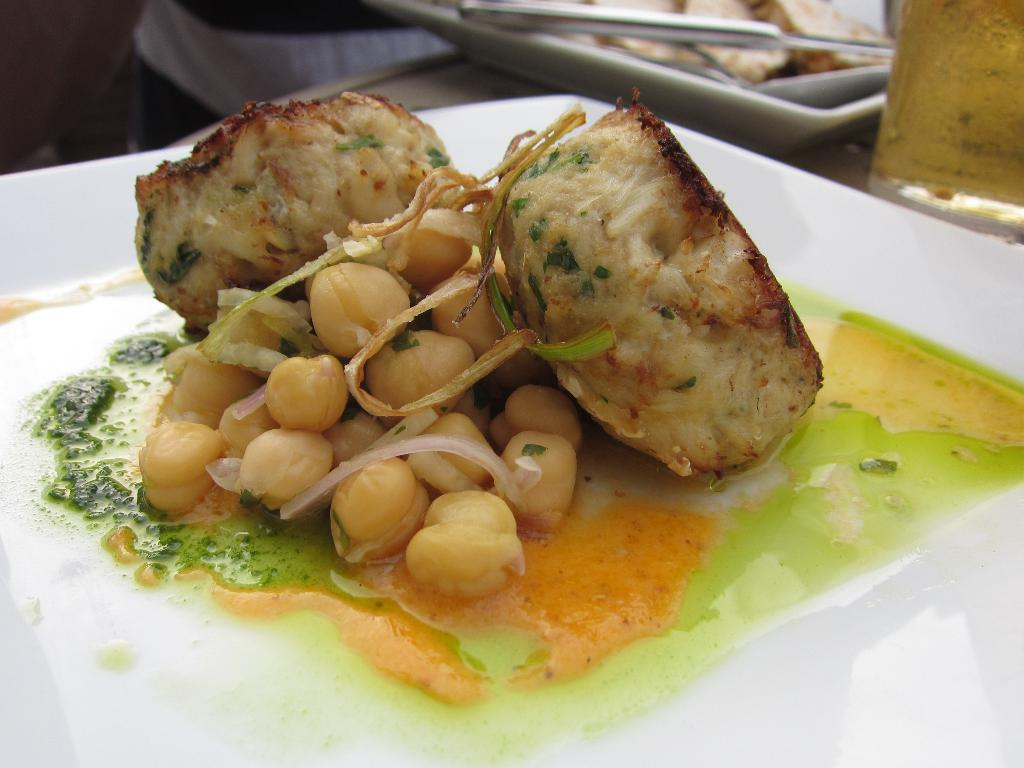What is on the plate that is visible in the image? There is a food item on a white plate in the image. Can you describe the arrangement of the plates in the image? There is another plate behind the first plate. Who or what is present in the image besides the plates? There is a person present in the image. What rhythm is the person in the image tapping out on the table? There is no indication in the image that the person is tapping out a rhythm on the table. 